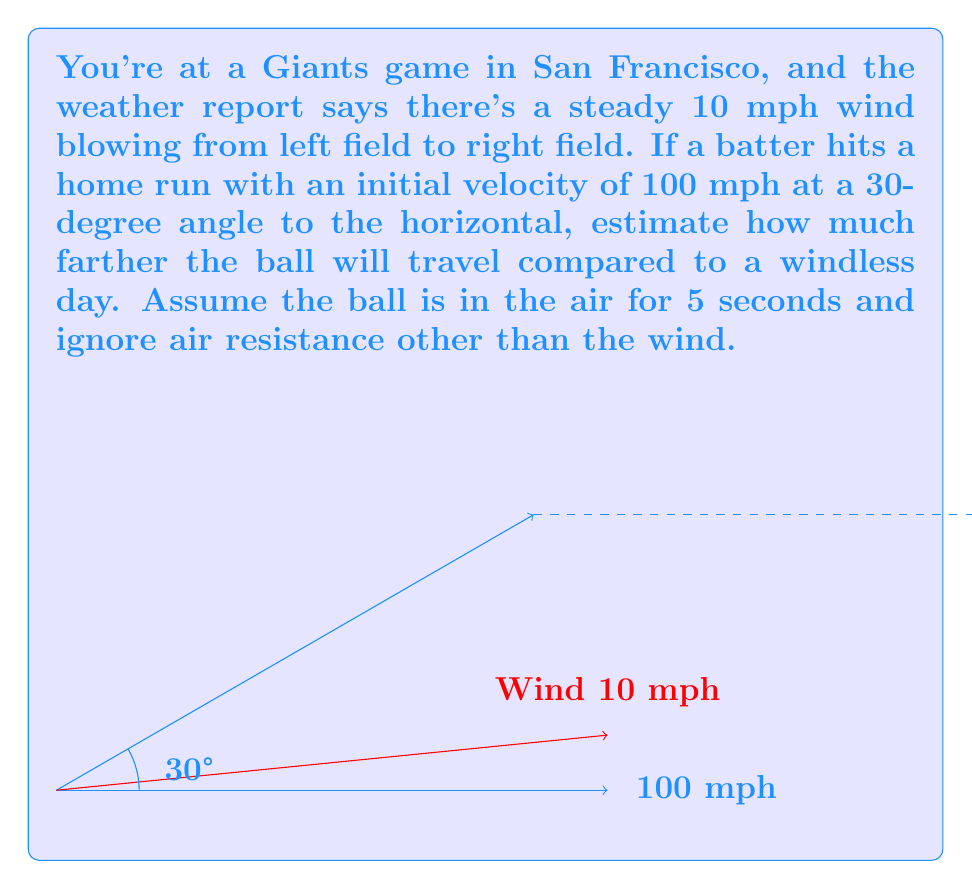Show me your answer to this math problem. Let's approach this step-by-step using vector calculus:

1) First, let's define our vectors. The initial velocity vector $\mathbf{v_0}$ in mph is:
   $$\mathbf{v_0} = (100 \cos 30°, 100 \sin 30°) = (86.6, 50)$$

2) The wind vector $\mathbf{w}$ in mph is:
   $$\mathbf{w} = (10, 0)$$

3) The total velocity vector $\mathbf{v}$ is the sum of these:
   $$\mathbf{v} = \mathbf{v_0} + \mathbf{w} = (96.6, 50)$$

4) To find the distance traveled, we need to integrate this velocity over time:
   $$\mathbf{d} = \int_0^t \mathbf{v} dt = (96.6t, 50t)$$

5) We're told the ball is in the air for 5 seconds, so let's substitute t = 5:
   $$\mathbf{d} = (483, 250)$$

6) The total distance traveled is the magnitude of this vector:
   $$|\mathbf{d}| = \sqrt{483^2 + 250^2} \approx 543.8 \text{ feet}$$

7) Without wind, the distance would have been:
   $$|\mathbf{d_0}| = \sqrt{(86.6 * 5)^2 + (50 * 5)^2} \approx 500 \text{ feet}$$

8) The difference is:
   $$543.8 - 500 \approx 43.8 \text{ feet}$$
Answer: Approximately 44 feet farther 